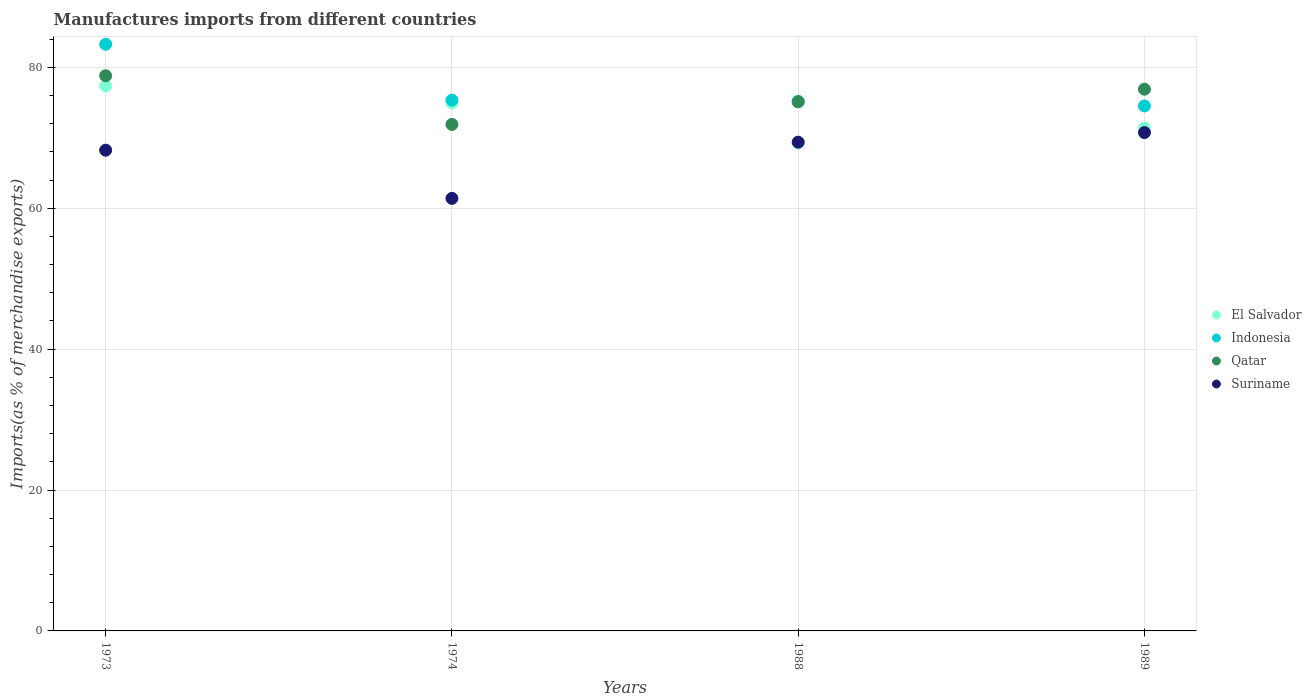How many different coloured dotlines are there?
Your answer should be very brief. 4. What is the percentage of imports to different countries in Suriname in 1974?
Keep it short and to the point. 61.41. Across all years, what is the maximum percentage of imports to different countries in Indonesia?
Offer a terse response. 83.28. Across all years, what is the minimum percentage of imports to different countries in Qatar?
Make the answer very short. 71.91. What is the total percentage of imports to different countries in Qatar in the graph?
Offer a very short reply. 302.75. What is the difference between the percentage of imports to different countries in Suriname in 1974 and that in 1988?
Offer a very short reply. -7.98. What is the difference between the percentage of imports to different countries in El Salvador in 1973 and the percentage of imports to different countries in Qatar in 1988?
Provide a succinct answer. 2.25. What is the average percentage of imports to different countries in Indonesia per year?
Provide a short and direct response. 77.09. In the year 1973, what is the difference between the percentage of imports to different countries in Indonesia and percentage of imports to different countries in El Salvador?
Ensure brevity in your answer.  5.92. What is the ratio of the percentage of imports to different countries in Qatar in 1973 to that in 1974?
Your answer should be compact. 1.1. What is the difference between the highest and the second highest percentage of imports to different countries in El Salvador?
Your response must be concise. 2.4. What is the difference between the highest and the lowest percentage of imports to different countries in Indonesia?
Your answer should be very brief. 8.76. Is the sum of the percentage of imports to different countries in Suriname in 1988 and 1989 greater than the maximum percentage of imports to different countries in El Salvador across all years?
Provide a succinct answer. Yes. Is the percentage of imports to different countries in Suriname strictly greater than the percentage of imports to different countries in El Salvador over the years?
Ensure brevity in your answer.  No. Is the percentage of imports to different countries in Indonesia strictly less than the percentage of imports to different countries in Suriname over the years?
Offer a very short reply. No. How many dotlines are there?
Provide a short and direct response. 4. How many years are there in the graph?
Keep it short and to the point. 4. How many legend labels are there?
Make the answer very short. 4. What is the title of the graph?
Provide a short and direct response. Manufactures imports from different countries. Does "Suriname" appear as one of the legend labels in the graph?
Ensure brevity in your answer.  Yes. What is the label or title of the Y-axis?
Make the answer very short. Imports(as % of merchandise exports). What is the Imports(as % of merchandise exports) in El Salvador in 1973?
Make the answer very short. 77.36. What is the Imports(as % of merchandise exports) of Indonesia in 1973?
Your response must be concise. 83.28. What is the Imports(as % of merchandise exports) in Qatar in 1973?
Offer a very short reply. 78.82. What is the Imports(as % of merchandise exports) in Suriname in 1973?
Give a very brief answer. 68.25. What is the Imports(as % of merchandise exports) in El Salvador in 1974?
Your answer should be compact. 74.96. What is the Imports(as % of merchandise exports) of Indonesia in 1974?
Make the answer very short. 75.35. What is the Imports(as % of merchandise exports) of Qatar in 1974?
Give a very brief answer. 71.91. What is the Imports(as % of merchandise exports) of Suriname in 1974?
Offer a terse response. 61.41. What is the Imports(as % of merchandise exports) of El Salvador in 1988?
Your response must be concise. 69.27. What is the Imports(as % of merchandise exports) of Indonesia in 1988?
Your response must be concise. 75.18. What is the Imports(as % of merchandise exports) in Qatar in 1988?
Give a very brief answer. 75.11. What is the Imports(as % of merchandise exports) of Suriname in 1988?
Offer a very short reply. 69.39. What is the Imports(as % of merchandise exports) of El Salvador in 1989?
Give a very brief answer. 71.39. What is the Imports(as % of merchandise exports) in Indonesia in 1989?
Provide a succinct answer. 74.53. What is the Imports(as % of merchandise exports) of Qatar in 1989?
Offer a terse response. 76.91. What is the Imports(as % of merchandise exports) in Suriname in 1989?
Provide a short and direct response. 70.75. Across all years, what is the maximum Imports(as % of merchandise exports) of El Salvador?
Keep it short and to the point. 77.36. Across all years, what is the maximum Imports(as % of merchandise exports) of Indonesia?
Offer a terse response. 83.28. Across all years, what is the maximum Imports(as % of merchandise exports) of Qatar?
Give a very brief answer. 78.82. Across all years, what is the maximum Imports(as % of merchandise exports) in Suriname?
Ensure brevity in your answer.  70.75. Across all years, what is the minimum Imports(as % of merchandise exports) of El Salvador?
Offer a terse response. 69.27. Across all years, what is the minimum Imports(as % of merchandise exports) in Indonesia?
Your answer should be very brief. 74.53. Across all years, what is the minimum Imports(as % of merchandise exports) of Qatar?
Provide a short and direct response. 71.91. Across all years, what is the minimum Imports(as % of merchandise exports) of Suriname?
Your response must be concise. 61.41. What is the total Imports(as % of merchandise exports) of El Salvador in the graph?
Give a very brief answer. 292.98. What is the total Imports(as % of merchandise exports) in Indonesia in the graph?
Your answer should be compact. 308.34. What is the total Imports(as % of merchandise exports) in Qatar in the graph?
Provide a short and direct response. 302.75. What is the total Imports(as % of merchandise exports) in Suriname in the graph?
Offer a terse response. 269.79. What is the difference between the Imports(as % of merchandise exports) in El Salvador in 1973 and that in 1974?
Give a very brief answer. 2.4. What is the difference between the Imports(as % of merchandise exports) of Indonesia in 1973 and that in 1974?
Give a very brief answer. 7.93. What is the difference between the Imports(as % of merchandise exports) of Qatar in 1973 and that in 1974?
Offer a very short reply. 6.91. What is the difference between the Imports(as % of merchandise exports) of Suriname in 1973 and that in 1974?
Make the answer very short. 6.84. What is the difference between the Imports(as % of merchandise exports) of El Salvador in 1973 and that in 1988?
Your answer should be very brief. 8.09. What is the difference between the Imports(as % of merchandise exports) in Indonesia in 1973 and that in 1988?
Ensure brevity in your answer.  8.1. What is the difference between the Imports(as % of merchandise exports) in Qatar in 1973 and that in 1988?
Make the answer very short. 3.7. What is the difference between the Imports(as % of merchandise exports) in Suriname in 1973 and that in 1988?
Provide a short and direct response. -1.14. What is the difference between the Imports(as % of merchandise exports) in El Salvador in 1973 and that in 1989?
Provide a short and direct response. 5.97. What is the difference between the Imports(as % of merchandise exports) in Indonesia in 1973 and that in 1989?
Your answer should be very brief. 8.76. What is the difference between the Imports(as % of merchandise exports) in Qatar in 1973 and that in 1989?
Give a very brief answer. 1.91. What is the difference between the Imports(as % of merchandise exports) in Suriname in 1973 and that in 1989?
Offer a very short reply. -2.5. What is the difference between the Imports(as % of merchandise exports) of El Salvador in 1974 and that in 1988?
Your answer should be compact. 5.69. What is the difference between the Imports(as % of merchandise exports) of Indonesia in 1974 and that in 1988?
Your answer should be compact. 0.17. What is the difference between the Imports(as % of merchandise exports) in Qatar in 1974 and that in 1988?
Keep it short and to the point. -3.21. What is the difference between the Imports(as % of merchandise exports) of Suriname in 1974 and that in 1988?
Keep it short and to the point. -7.98. What is the difference between the Imports(as % of merchandise exports) of El Salvador in 1974 and that in 1989?
Keep it short and to the point. 3.57. What is the difference between the Imports(as % of merchandise exports) in Indonesia in 1974 and that in 1989?
Make the answer very short. 0.82. What is the difference between the Imports(as % of merchandise exports) of Qatar in 1974 and that in 1989?
Keep it short and to the point. -5. What is the difference between the Imports(as % of merchandise exports) of Suriname in 1974 and that in 1989?
Provide a succinct answer. -9.34. What is the difference between the Imports(as % of merchandise exports) of El Salvador in 1988 and that in 1989?
Your answer should be very brief. -2.12. What is the difference between the Imports(as % of merchandise exports) in Indonesia in 1988 and that in 1989?
Keep it short and to the point. 0.65. What is the difference between the Imports(as % of merchandise exports) of Qatar in 1988 and that in 1989?
Offer a very short reply. -1.8. What is the difference between the Imports(as % of merchandise exports) in Suriname in 1988 and that in 1989?
Ensure brevity in your answer.  -1.36. What is the difference between the Imports(as % of merchandise exports) in El Salvador in 1973 and the Imports(as % of merchandise exports) in Indonesia in 1974?
Give a very brief answer. 2.01. What is the difference between the Imports(as % of merchandise exports) of El Salvador in 1973 and the Imports(as % of merchandise exports) of Qatar in 1974?
Give a very brief answer. 5.46. What is the difference between the Imports(as % of merchandise exports) in El Salvador in 1973 and the Imports(as % of merchandise exports) in Suriname in 1974?
Keep it short and to the point. 15.95. What is the difference between the Imports(as % of merchandise exports) of Indonesia in 1973 and the Imports(as % of merchandise exports) of Qatar in 1974?
Offer a terse response. 11.38. What is the difference between the Imports(as % of merchandise exports) of Indonesia in 1973 and the Imports(as % of merchandise exports) of Suriname in 1974?
Your response must be concise. 21.88. What is the difference between the Imports(as % of merchandise exports) in Qatar in 1973 and the Imports(as % of merchandise exports) in Suriname in 1974?
Offer a very short reply. 17.41. What is the difference between the Imports(as % of merchandise exports) in El Salvador in 1973 and the Imports(as % of merchandise exports) in Indonesia in 1988?
Make the answer very short. 2.18. What is the difference between the Imports(as % of merchandise exports) in El Salvador in 1973 and the Imports(as % of merchandise exports) in Qatar in 1988?
Provide a succinct answer. 2.25. What is the difference between the Imports(as % of merchandise exports) in El Salvador in 1973 and the Imports(as % of merchandise exports) in Suriname in 1988?
Provide a short and direct response. 7.97. What is the difference between the Imports(as % of merchandise exports) of Indonesia in 1973 and the Imports(as % of merchandise exports) of Qatar in 1988?
Your answer should be very brief. 8.17. What is the difference between the Imports(as % of merchandise exports) in Indonesia in 1973 and the Imports(as % of merchandise exports) in Suriname in 1988?
Keep it short and to the point. 13.9. What is the difference between the Imports(as % of merchandise exports) in Qatar in 1973 and the Imports(as % of merchandise exports) in Suriname in 1988?
Keep it short and to the point. 9.43. What is the difference between the Imports(as % of merchandise exports) in El Salvador in 1973 and the Imports(as % of merchandise exports) in Indonesia in 1989?
Offer a very short reply. 2.83. What is the difference between the Imports(as % of merchandise exports) in El Salvador in 1973 and the Imports(as % of merchandise exports) in Qatar in 1989?
Provide a succinct answer. 0.45. What is the difference between the Imports(as % of merchandise exports) of El Salvador in 1973 and the Imports(as % of merchandise exports) of Suriname in 1989?
Your answer should be very brief. 6.61. What is the difference between the Imports(as % of merchandise exports) in Indonesia in 1973 and the Imports(as % of merchandise exports) in Qatar in 1989?
Your response must be concise. 6.37. What is the difference between the Imports(as % of merchandise exports) of Indonesia in 1973 and the Imports(as % of merchandise exports) of Suriname in 1989?
Provide a short and direct response. 12.54. What is the difference between the Imports(as % of merchandise exports) of Qatar in 1973 and the Imports(as % of merchandise exports) of Suriname in 1989?
Provide a succinct answer. 8.07. What is the difference between the Imports(as % of merchandise exports) of El Salvador in 1974 and the Imports(as % of merchandise exports) of Indonesia in 1988?
Offer a terse response. -0.22. What is the difference between the Imports(as % of merchandise exports) in El Salvador in 1974 and the Imports(as % of merchandise exports) in Qatar in 1988?
Keep it short and to the point. -0.15. What is the difference between the Imports(as % of merchandise exports) in El Salvador in 1974 and the Imports(as % of merchandise exports) in Suriname in 1988?
Your response must be concise. 5.57. What is the difference between the Imports(as % of merchandise exports) of Indonesia in 1974 and the Imports(as % of merchandise exports) of Qatar in 1988?
Make the answer very short. 0.24. What is the difference between the Imports(as % of merchandise exports) in Indonesia in 1974 and the Imports(as % of merchandise exports) in Suriname in 1988?
Give a very brief answer. 5.96. What is the difference between the Imports(as % of merchandise exports) of Qatar in 1974 and the Imports(as % of merchandise exports) of Suriname in 1988?
Offer a terse response. 2.52. What is the difference between the Imports(as % of merchandise exports) in El Salvador in 1974 and the Imports(as % of merchandise exports) in Indonesia in 1989?
Your answer should be compact. 0.43. What is the difference between the Imports(as % of merchandise exports) of El Salvador in 1974 and the Imports(as % of merchandise exports) of Qatar in 1989?
Keep it short and to the point. -1.95. What is the difference between the Imports(as % of merchandise exports) of El Salvador in 1974 and the Imports(as % of merchandise exports) of Suriname in 1989?
Make the answer very short. 4.21. What is the difference between the Imports(as % of merchandise exports) of Indonesia in 1974 and the Imports(as % of merchandise exports) of Qatar in 1989?
Keep it short and to the point. -1.56. What is the difference between the Imports(as % of merchandise exports) in Indonesia in 1974 and the Imports(as % of merchandise exports) in Suriname in 1989?
Provide a short and direct response. 4.6. What is the difference between the Imports(as % of merchandise exports) in Qatar in 1974 and the Imports(as % of merchandise exports) in Suriname in 1989?
Offer a very short reply. 1.16. What is the difference between the Imports(as % of merchandise exports) of El Salvador in 1988 and the Imports(as % of merchandise exports) of Indonesia in 1989?
Your answer should be compact. -5.25. What is the difference between the Imports(as % of merchandise exports) in El Salvador in 1988 and the Imports(as % of merchandise exports) in Qatar in 1989?
Provide a short and direct response. -7.64. What is the difference between the Imports(as % of merchandise exports) in El Salvador in 1988 and the Imports(as % of merchandise exports) in Suriname in 1989?
Your answer should be compact. -1.48. What is the difference between the Imports(as % of merchandise exports) of Indonesia in 1988 and the Imports(as % of merchandise exports) of Qatar in 1989?
Ensure brevity in your answer.  -1.73. What is the difference between the Imports(as % of merchandise exports) in Indonesia in 1988 and the Imports(as % of merchandise exports) in Suriname in 1989?
Offer a very short reply. 4.43. What is the difference between the Imports(as % of merchandise exports) in Qatar in 1988 and the Imports(as % of merchandise exports) in Suriname in 1989?
Offer a terse response. 4.37. What is the average Imports(as % of merchandise exports) in El Salvador per year?
Ensure brevity in your answer.  73.25. What is the average Imports(as % of merchandise exports) in Indonesia per year?
Offer a terse response. 77.09. What is the average Imports(as % of merchandise exports) of Qatar per year?
Keep it short and to the point. 75.69. What is the average Imports(as % of merchandise exports) in Suriname per year?
Offer a terse response. 67.45. In the year 1973, what is the difference between the Imports(as % of merchandise exports) in El Salvador and Imports(as % of merchandise exports) in Indonesia?
Your answer should be very brief. -5.92. In the year 1973, what is the difference between the Imports(as % of merchandise exports) in El Salvador and Imports(as % of merchandise exports) in Qatar?
Keep it short and to the point. -1.46. In the year 1973, what is the difference between the Imports(as % of merchandise exports) in El Salvador and Imports(as % of merchandise exports) in Suriname?
Provide a short and direct response. 9.11. In the year 1973, what is the difference between the Imports(as % of merchandise exports) of Indonesia and Imports(as % of merchandise exports) of Qatar?
Offer a terse response. 4.47. In the year 1973, what is the difference between the Imports(as % of merchandise exports) of Indonesia and Imports(as % of merchandise exports) of Suriname?
Offer a very short reply. 15.04. In the year 1973, what is the difference between the Imports(as % of merchandise exports) of Qatar and Imports(as % of merchandise exports) of Suriname?
Provide a succinct answer. 10.57. In the year 1974, what is the difference between the Imports(as % of merchandise exports) of El Salvador and Imports(as % of merchandise exports) of Indonesia?
Keep it short and to the point. -0.39. In the year 1974, what is the difference between the Imports(as % of merchandise exports) of El Salvador and Imports(as % of merchandise exports) of Qatar?
Keep it short and to the point. 3.05. In the year 1974, what is the difference between the Imports(as % of merchandise exports) in El Salvador and Imports(as % of merchandise exports) in Suriname?
Provide a short and direct response. 13.55. In the year 1974, what is the difference between the Imports(as % of merchandise exports) of Indonesia and Imports(as % of merchandise exports) of Qatar?
Your answer should be very brief. 3.45. In the year 1974, what is the difference between the Imports(as % of merchandise exports) in Indonesia and Imports(as % of merchandise exports) in Suriname?
Offer a very short reply. 13.94. In the year 1974, what is the difference between the Imports(as % of merchandise exports) in Qatar and Imports(as % of merchandise exports) in Suriname?
Make the answer very short. 10.5. In the year 1988, what is the difference between the Imports(as % of merchandise exports) of El Salvador and Imports(as % of merchandise exports) of Indonesia?
Keep it short and to the point. -5.91. In the year 1988, what is the difference between the Imports(as % of merchandise exports) in El Salvador and Imports(as % of merchandise exports) in Qatar?
Make the answer very short. -5.84. In the year 1988, what is the difference between the Imports(as % of merchandise exports) in El Salvador and Imports(as % of merchandise exports) in Suriname?
Provide a succinct answer. -0.11. In the year 1988, what is the difference between the Imports(as % of merchandise exports) of Indonesia and Imports(as % of merchandise exports) of Qatar?
Your response must be concise. 0.07. In the year 1988, what is the difference between the Imports(as % of merchandise exports) of Indonesia and Imports(as % of merchandise exports) of Suriname?
Your answer should be compact. 5.79. In the year 1988, what is the difference between the Imports(as % of merchandise exports) of Qatar and Imports(as % of merchandise exports) of Suriname?
Your response must be concise. 5.73. In the year 1989, what is the difference between the Imports(as % of merchandise exports) in El Salvador and Imports(as % of merchandise exports) in Indonesia?
Provide a short and direct response. -3.14. In the year 1989, what is the difference between the Imports(as % of merchandise exports) of El Salvador and Imports(as % of merchandise exports) of Qatar?
Offer a very short reply. -5.52. In the year 1989, what is the difference between the Imports(as % of merchandise exports) in El Salvador and Imports(as % of merchandise exports) in Suriname?
Offer a terse response. 0.64. In the year 1989, what is the difference between the Imports(as % of merchandise exports) in Indonesia and Imports(as % of merchandise exports) in Qatar?
Give a very brief answer. -2.38. In the year 1989, what is the difference between the Imports(as % of merchandise exports) of Indonesia and Imports(as % of merchandise exports) of Suriname?
Your response must be concise. 3.78. In the year 1989, what is the difference between the Imports(as % of merchandise exports) of Qatar and Imports(as % of merchandise exports) of Suriname?
Keep it short and to the point. 6.16. What is the ratio of the Imports(as % of merchandise exports) in El Salvador in 1973 to that in 1974?
Provide a succinct answer. 1.03. What is the ratio of the Imports(as % of merchandise exports) of Indonesia in 1973 to that in 1974?
Your answer should be very brief. 1.11. What is the ratio of the Imports(as % of merchandise exports) of Qatar in 1973 to that in 1974?
Make the answer very short. 1.1. What is the ratio of the Imports(as % of merchandise exports) of Suriname in 1973 to that in 1974?
Offer a very short reply. 1.11. What is the ratio of the Imports(as % of merchandise exports) of El Salvador in 1973 to that in 1988?
Provide a short and direct response. 1.12. What is the ratio of the Imports(as % of merchandise exports) of Indonesia in 1973 to that in 1988?
Offer a terse response. 1.11. What is the ratio of the Imports(as % of merchandise exports) of Qatar in 1973 to that in 1988?
Your response must be concise. 1.05. What is the ratio of the Imports(as % of merchandise exports) in Suriname in 1973 to that in 1988?
Make the answer very short. 0.98. What is the ratio of the Imports(as % of merchandise exports) of El Salvador in 1973 to that in 1989?
Give a very brief answer. 1.08. What is the ratio of the Imports(as % of merchandise exports) in Indonesia in 1973 to that in 1989?
Provide a succinct answer. 1.12. What is the ratio of the Imports(as % of merchandise exports) of Qatar in 1973 to that in 1989?
Your response must be concise. 1.02. What is the ratio of the Imports(as % of merchandise exports) in Suriname in 1973 to that in 1989?
Your answer should be very brief. 0.96. What is the ratio of the Imports(as % of merchandise exports) of El Salvador in 1974 to that in 1988?
Your answer should be compact. 1.08. What is the ratio of the Imports(as % of merchandise exports) of Indonesia in 1974 to that in 1988?
Your answer should be compact. 1. What is the ratio of the Imports(as % of merchandise exports) in Qatar in 1974 to that in 1988?
Give a very brief answer. 0.96. What is the ratio of the Imports(as % of merchandise exports) in Suriname in 1974 to that in 1988?
Ensure brevity in your answer.  0.89. What is the ratio of the Imports(as % of merchandise exports) of El Salvador in 1974 to that in 1989?
Keep it short and to the point. 1.05. What is the ratio of the Imports(as % of merchandise exports) in Indonesia in 1974 to that in 1989?
Your response must be concise. 1.01. What is the ratio of the Imports(as % of merchandise exports) of Qatar in 1974 to that in 1989?
Provide a succinct answer. 0.93. What is the ratio of the Imports(as % of merchandise exports) in Suriname in 1974 to that in 1989?
Offer a very short reply. 0.87. What is the ratio of the Imports(as % of merchandise exports) of El Salvador in 1988 to that in 1989?
Your response must be concise. 0.97. What is the ratio of the Imports(as % of merchandise exports) of Indonesia in 1988 to that in 1989?
Your answer should be compact. 1.01. What is the ratio of the Imports(as % of merchandise exports) in Qatar in 1988 to that in 1989?
Provide a succinct answer. 0.98. What is the ratio of the Imports(as % of merchandise exports) of Suriname in 1988 to that in 1989?
Your answer should be compact. 0.98. What is the difference between the highest and the second highest Imports(as % of merchandise exports) of El Salvador?
Provide a succinct answer. 2.4. What is the difference between the highest and the second highest Imports(as % of merchandise exports) of Indonesia?
Ensure brevity in your answer.  7.93. What is the difference between the highest and the second highest Imports(as % of merchandise exports) in Qatar?
Offer a very short reply. 1.91. What is the difference between the highest and the second highest Imports(as % of merchandise exports) in Suriname?
Keep it short and to the point. 1.36. What is the difference between the highest and the lowest Imports(as % of merchandise exports) in El Salvador?
Your answer should be compact. 8.09. What is the difference between the highest and the lowest Imports(as % of merchandise exports) of Indonesia?
Offer a very short reply. 8.76. What is the difference between the highest and the lowest Imports(as % of merchandise exports) of Qatar?
Provide a succinct answer. 6.91. What is the difference between the highest and the lowest Imports(as % of merchandise exports) of Suriname?
Keep it short and to the point. 9.34. 